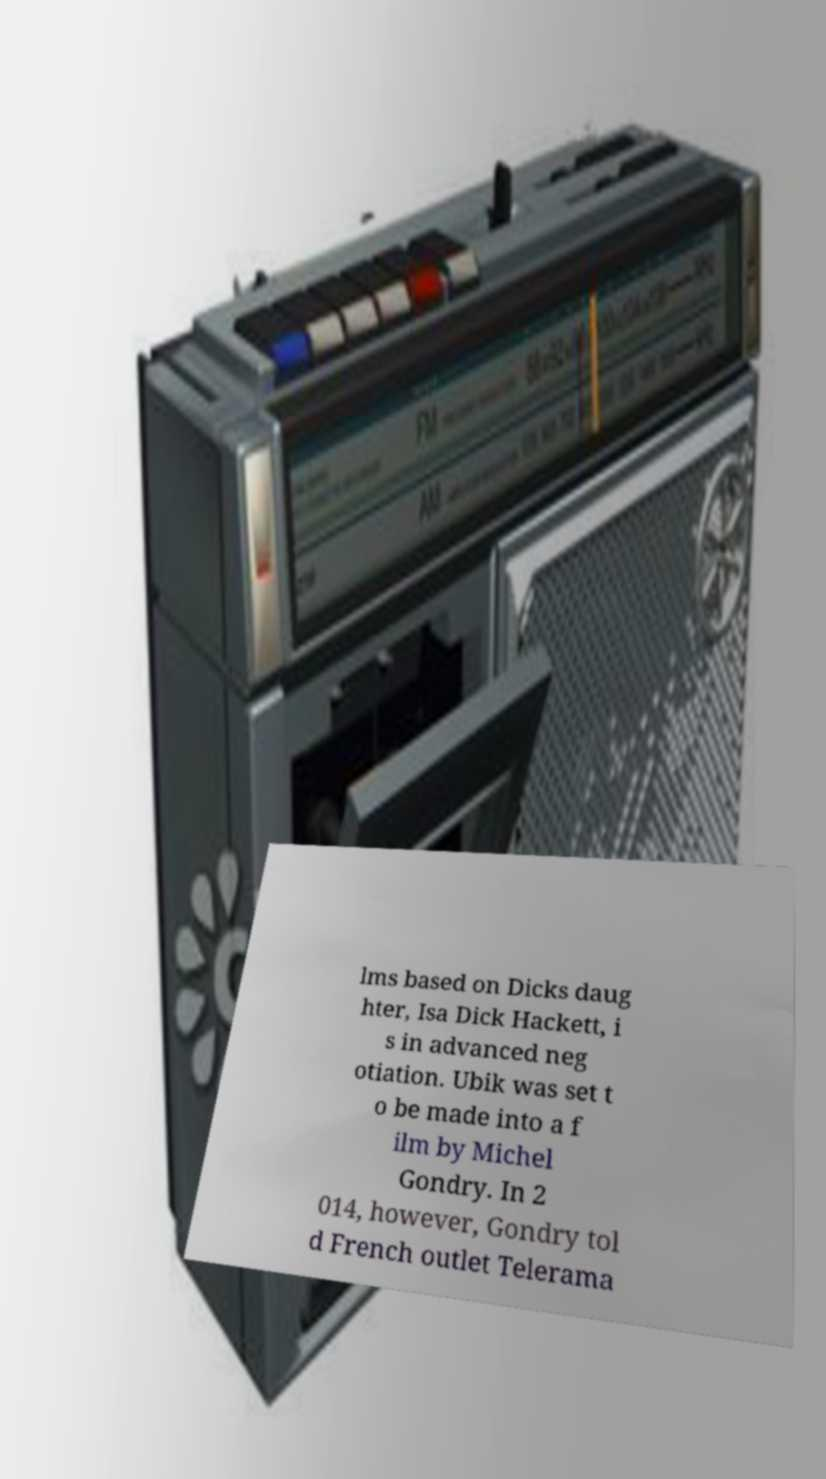For documentation purposes, I need the text within this image transcribed. Could you provide that? lms based on Dicks daug hter, Isa Dick Hackett, i s in advanced neg otiation. Ubik was set t o be made into a f ilm by Michel Gondry. In 2 014, however, Gondry tol d French outlet Telerama 